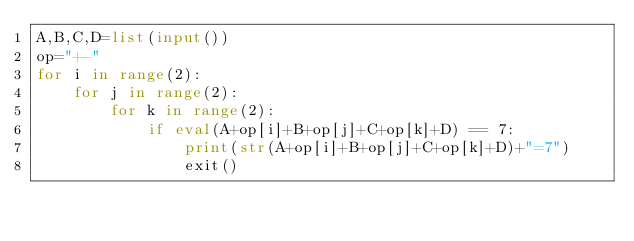Convert code to text. <code><loc_0><loc_0><loc_500><loc_500><_Python_>A,B,C,D=list(input())
op="+-"
for i in range(2):
    for j in range(2):
        for k in range(2):
            if eval(A+op[i]+B+op[j]+C+op[k]+D) == 7:
                print(str(A+op[i]+B+op[j]+C+op[k]+D)+"=7")
                exit()
</code> 